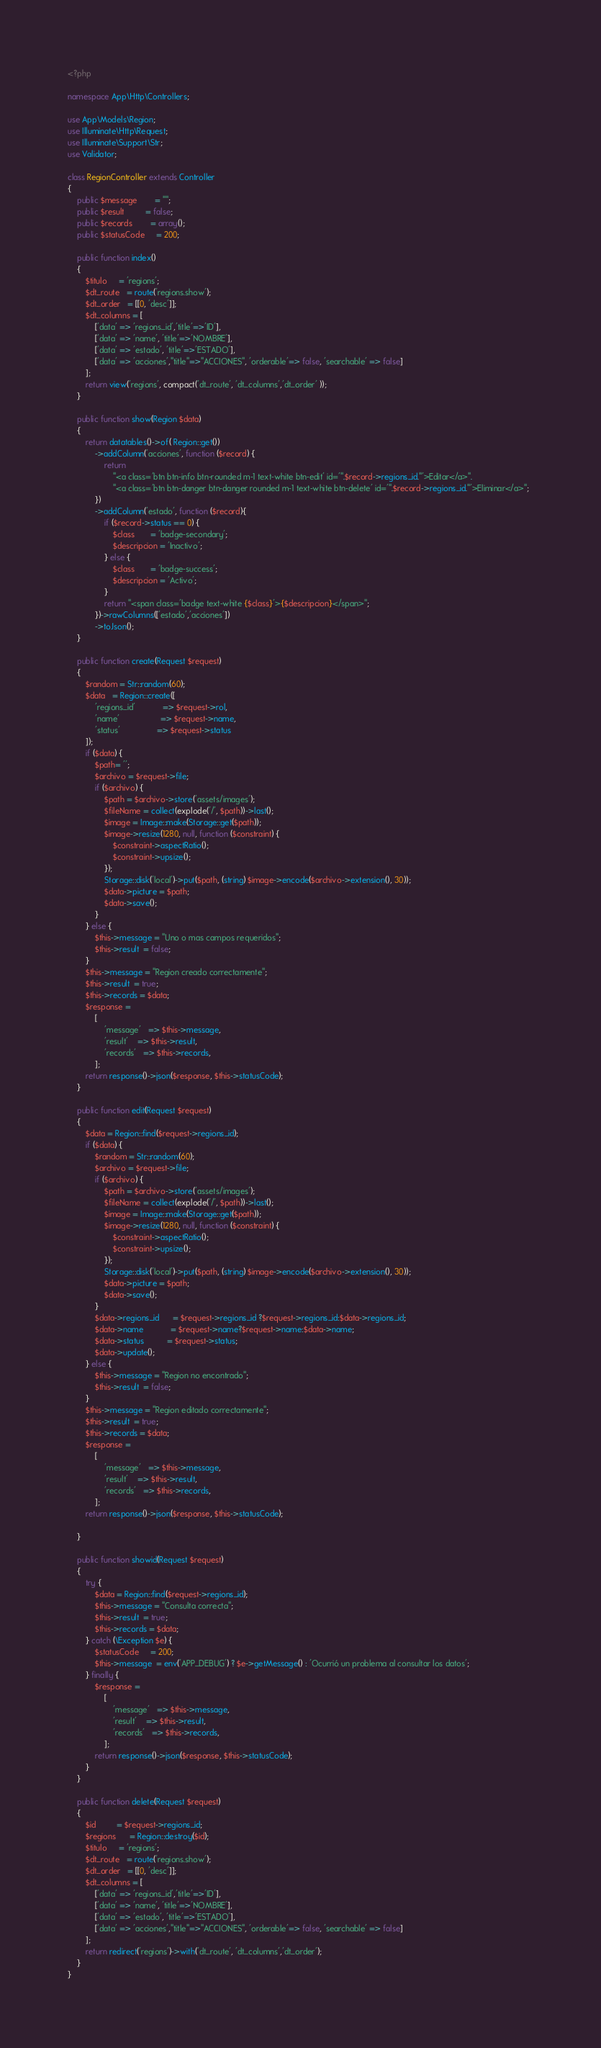Convert code to text. <code><loc_0><loc_0><loc_500><loc_500><_PHP_><?php

namespace App\Http\Controllers;

use App\Models\Region;
use Illuminate\Http\Request;
use Illuminate\Support\Str;
use Validator;

class RegionController extends Controller
{
    public $message        = "";
    public $result         = false;
    public $records        = array();
    public $statusCode     = 200;
    
    public function index()
    {
        $titulo     = 'regions';
        $dt_route   = route('regions.show');
        $dt_order   = [[0, 'desc']];
        $dt_columns = [
            ['data' => 'regions_id','title'=>'ID'],
            ['data' => 'name', 'title'=>'NOMBRE'],
            ['data' => 'estado', 'title'=>'ESTADO'],
            ['data' => 'acciones',"title"=>"ACCIONES", 'orderable'=> false, 'searchable' => false]
        ]; 
        return view('regions', compact('dt_route', 'dt_columns','dt_order' ));
    }
    
    public function show(Region $data)
    {
        return datatables()->of( Region::get())
            ->addColumn('acciones', function ($record) {
                return
                    "<a class='btn btn-info btn-rounded m-1 text-white btn-edit' id='".$record->regions_id."'>Editar</a>".
                    "<a class='btn btn-danger btn-danger rounded m-1 text-white btn-delete' id='".$record->regions_id."'>Eliminar</a>";  
            })
            ->addColumn('estado', function ($record){
                if ($record->status == 0) {
                    $class       = 'badge-secondary';
                    $descripcion = 'Inactivo';
                } else {
                    $class       = 'badge-success';
                    $descripcion = 'Activo';
                }
                return "<span class='badge text-white {$class}'>{$descripcion}</span>";
            })->rawColumns(['estado','acciones'])
            ->toJson();
    }

    public function create(Request $request)
    {
        $random = Str::random(60);
        $data   = Region::create([
            'regions_id'            => $request->rol,
            'name'                  => $request->name,
            'status'                => $request->status
        ]);
        if ($data) {
            $path= '';
            $archivo = $request->file;
            if ($archivo) {
                $path = $archivo->store('assets/images');
                $fileName = collect(explode('/', $path))->last();
                $image = Image::make(Storage::get($path));
                $image->resize(1280, null, function ($constraint) {
                    $constraint->aspectRatio();
                    $constraint->upsize();
                });
                Storage::disk('local')->put($path, (string) $image->encode($archivo->extension(), 30));
                $data->picture = $path;
                $data->save();
            }
        } else {
            $this->message = "Uno o mas campos requeridos";
            $this->result  = false;
        }
        $this->message = "Region creado correctamente";
        $this->result  = true;
        $this->records = $data;
        $response =
            [
                'message'   => $this->message,
                'result'    => $this->result,
                'records'   => $this->records,
            ];
        return response()->json($response, $this->statusCode);
    }

    public function edit(Request $request)
    {
        $data = Region::find($request->regions_id);
        if ($data) {
            $random = Str::random(60);
            $archivo = $request->file;
            if ($archivo) {
                $path = $archivo->store('assets/images');
                $fileName = collect(explode('/', $path))->last();
                $image = Image::make(Storage::get($path));
                $image->resize(1280, null, function ($constraint) {
                    $constraint->aspectRatio();
                    $constraint->upsize();
                });
                Storage::disk('local')->put($path, (string) $image->encode($archivo->extension(), 30));
                $data->picture = $path;
                $data->save();
            }
            $data->regions_id      = $request->regions_id ?$request->regions_id:$data->regions_id;
            $data->name            = $request->name?$request->name:$data->name;
            $data->status          = $request->status;
            $data->update();
        } else {
            $this->message = "Region no encontrado";
            $this->result  = false;
        }
        $this->message = "Region editado correctamente";
        $this->result  = true;
        $this->records = $data;
        $response =
            [
                'message'   => $this->message,
                'result'    => $this->result,
                'records'   => $this->records,
            ];
        return response()->json($response, $this->statusCode);
        
    }

    public function showid(Request $request)
    {
        try {
            $data = Region::find($request->regions_id);
            $this->message = "Consulta correcta";
            $this->result  = true;
            $this->records = $data;
        } catch (\Exception $e) {
            $statusCode     = 200;
            $this->message  = env('APP_DEBUG') ? $e->getMessage() : 'Ocurrió un problema al consultar los datos';
        } finally {
            $response =
                [
                    'message'   => $this->message,
                    'result'    => $this->result,
                    'records'   => $this->records,
                ];
            return response()->json($response, $this->statusCode);
        }
    }

    public function delete(Request $request)
    {
        $id         = $request->regions_id;
        $regions      = Region::destroy($id);
        $titulo     = 'regions';
        $dt_route   = route('regions.show');
        $dt_order   = [[0, 'desc']];
        $dt_columns = [
            ['data' => 'regions_id','title'=>'ID'],
            ['data' => 'name', 'title'=>'NOMBRE'],
            ['data' => 'estado', 'title'=>'ESTADO'],
            ['data' => 'acciones',"title"=>"ACCIONES", 'orderable'=> false, 'searchable' => false]
        ]; 
        return redirect('regions')->with('dt_route', 'dt_columns','dt_order');
    }
}
</code> 